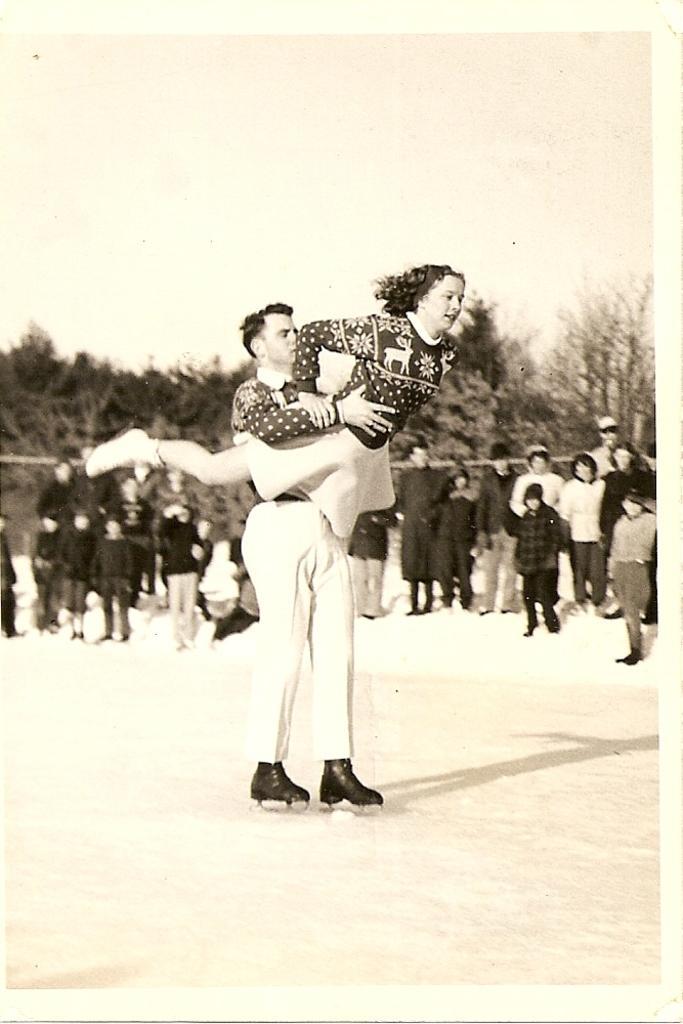In one or two sentences, can you explain what this image depicts? This is black and white image. Hear I can see a man is carrying a woman in the hands and standing on the ground. In the background, I can see few people are standing and looking at this man. In the background there are some trees. On the top of the image I can see the sky. 